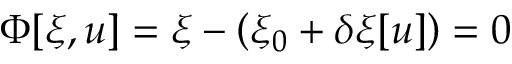<formula> <loc_0><loc_0><loc_500><loc_500>\Phi [ \xi , u ] = \xi - \left ( \xi _ { 0 } + \delta \xi [ u ] \right ) = 0 \</formula> 